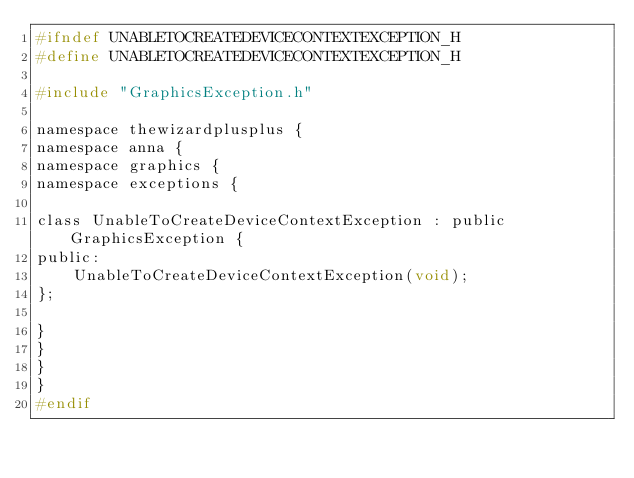Convert code to text. <code><loc_0><loc_0><loc_500><loc_500><_C_>#ifndef UNABLETOCREATEDEVICECONTEXTEXCEPTION_H
#define UNABLETOCREATEDEVICECONTEXTEXCEPTION_H

#include "GraphicsException.h"

namespace thewizardplusplus {
namespace anna {
namespace graphics {
namespace exceptions {

class UnableToCreateDeviceContextException : public GraphicsException {
public:
	UnableToCreateDeviceContextException(void);
};

}
}
}
}
#endif
</code> 